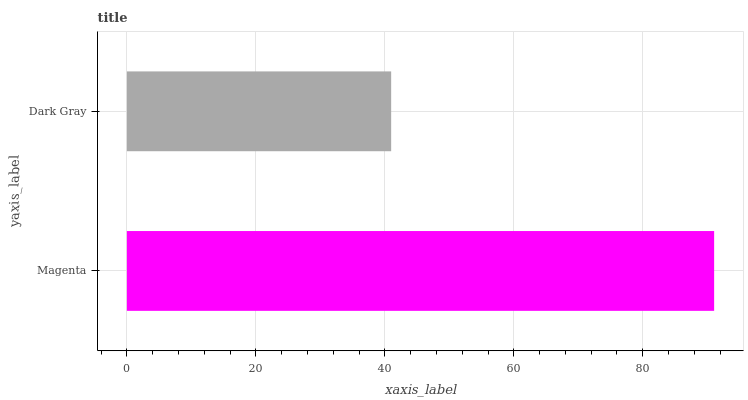Is Dark Gray the minimum?
Answer yes or no. Yes. Is Magenta the maximum?
Answer yes or no. Yes. Is Dark Gray the maximum?
Answer yes or no. No. Is Magenta greater than Dark Gray?
Answer yes or no. Yes. Is Dark Gray less than Magenta?
Answer yes or no. Yes. Is Dark Gray greater than Magenta?
Answer yes or no. No. Is Magenta less than Dark Gray?
Answer yes or no. No. Is Magenta the high median?
Answer yes or no. Yes. Is Dark Gray the low median?
Answer yes or no. Yes. Is Dark Gray the high median?
Answer yes or no. No. Is Magenta the low median?
Answer yes or no. No. 